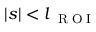<formula> <loc_0><loc_0><loc_500><loc_500>| s | < l _ { R O I }</formula> 